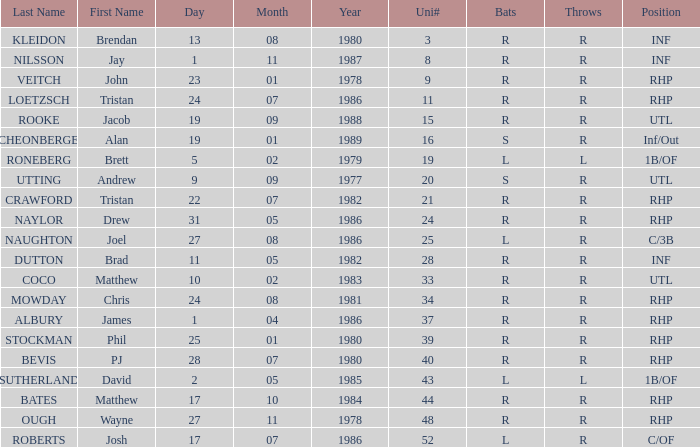Which Uni # has a Surname of ough? 48.0. 